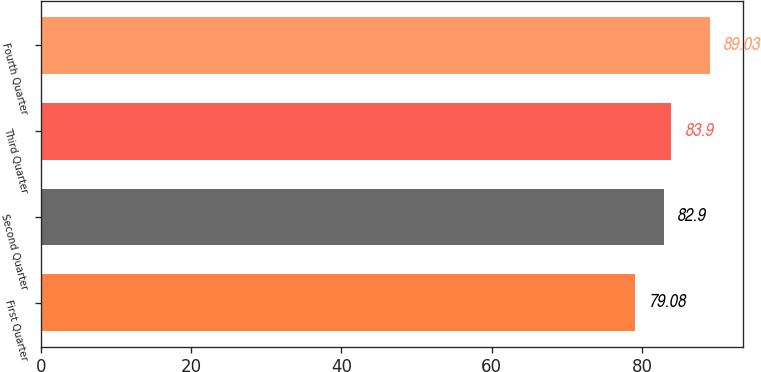<chart> <loc_0><loc_0><loc_500><loc_500><bar_chart><fcel>First Quarter<fcel>Second Quarter<fcel>Third Quarter<fcel>Fourth Quarter<nl><fcel>79.08<fcel>82.9<fcel>83.9<fcel>89.03<nl></chart> 